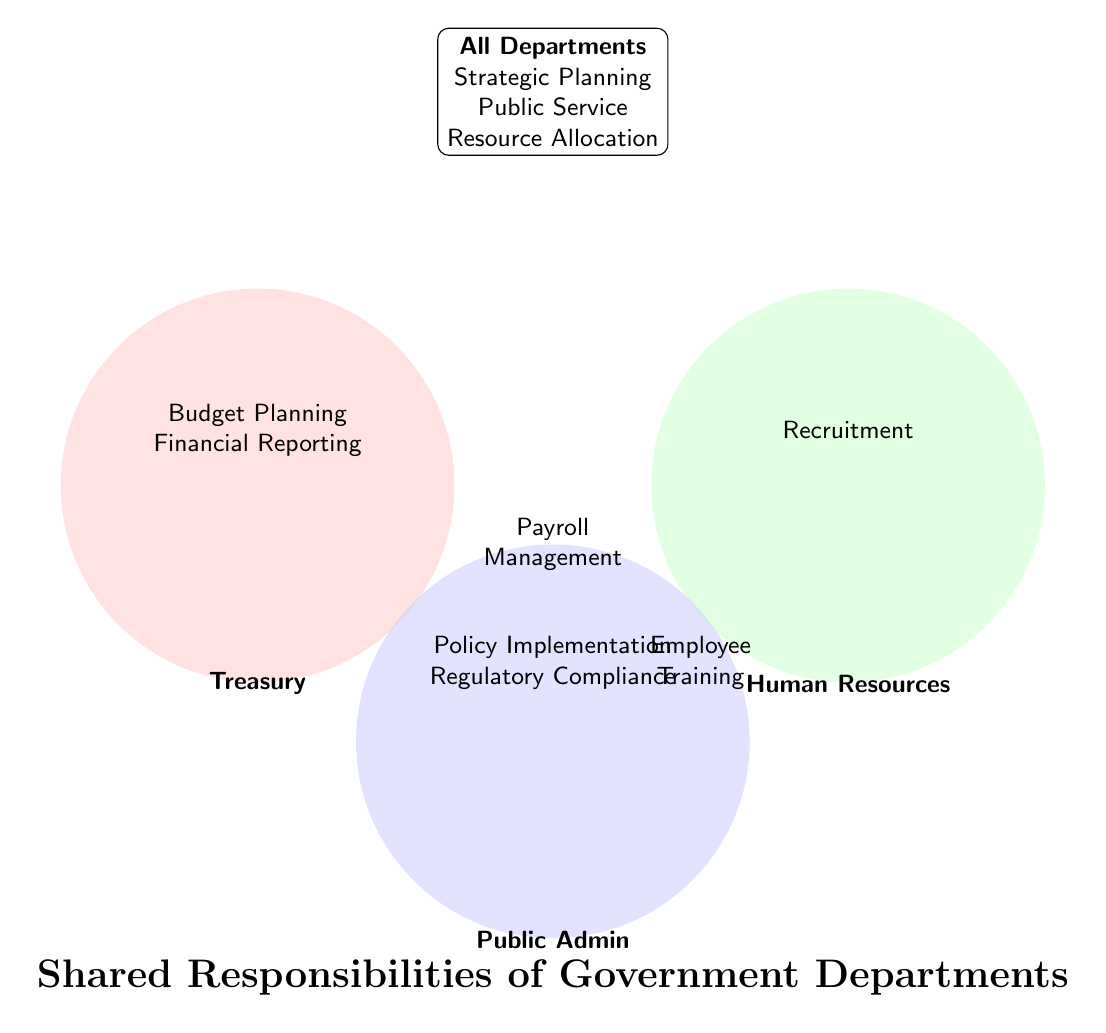What is the title of the figure? The title of the figure is displayed prominently at the bottom. The large, bold text reads "Shared Responsibilities of Government Departments"
Answer: Shared Responsibilities of Government Departments Which department is responsible for Recruitment? The figure shows each department’s responsibilities. The text, "Recruitment" is inside the Human Resources circle.
Answer: Human Resources Name one responsibility shared by Treasury and Human Resources. Looking at the areas where the circles for both Treasury and Human Resources overlap, we see "Payroll Management".
Answer: Payroll Management How many departments share the responsibility of Employee Training? The diagram shows that Employee Training is in the overlapping area of Human Resources and Public Admin. So, two departments share this responsibility.
Answer: Two Which departments share the responsibility of Payroll Management? The area where the circles for Treasury and Human Resources overlap shows "Payroll Management", indicating that both departments share this responsibility.
Answer: Treasury and Human Resources List all the responsibilities of Public Administration. The text within Public Administration’s circle and the overlapping areas give the responsibilities: Policy Implementation, Regulatory Compliance, and Employee Training.
Answer: Policy Implementation, Regulatory Compliance, Employee Training Which responsibilities are shared by all departments? The box at the top lists responsibilities shared by all departments: Strategic Planning, Public Service, and Resource Allocation.
Answer: Strategic Planning, Public Service, Resource Allocation Compare the number of unique responsibilities of Treasury and Human Resources. Which one has more? The Treasury has two unique responsibilities (Budget Planning, Financial Reporting) while Human Resources has one (Recruitment). Treasury has more unique responsibilities.
Answer: Treasury What is a common responsibility among Treasury, Human Resources, and Public Administration? The middle overlapping regions show shared responsibilities. "Employee Training" overlaps between Human Resources and Public Admin but not Treasury, so there is no common responsibility among all three.
Answer: None 